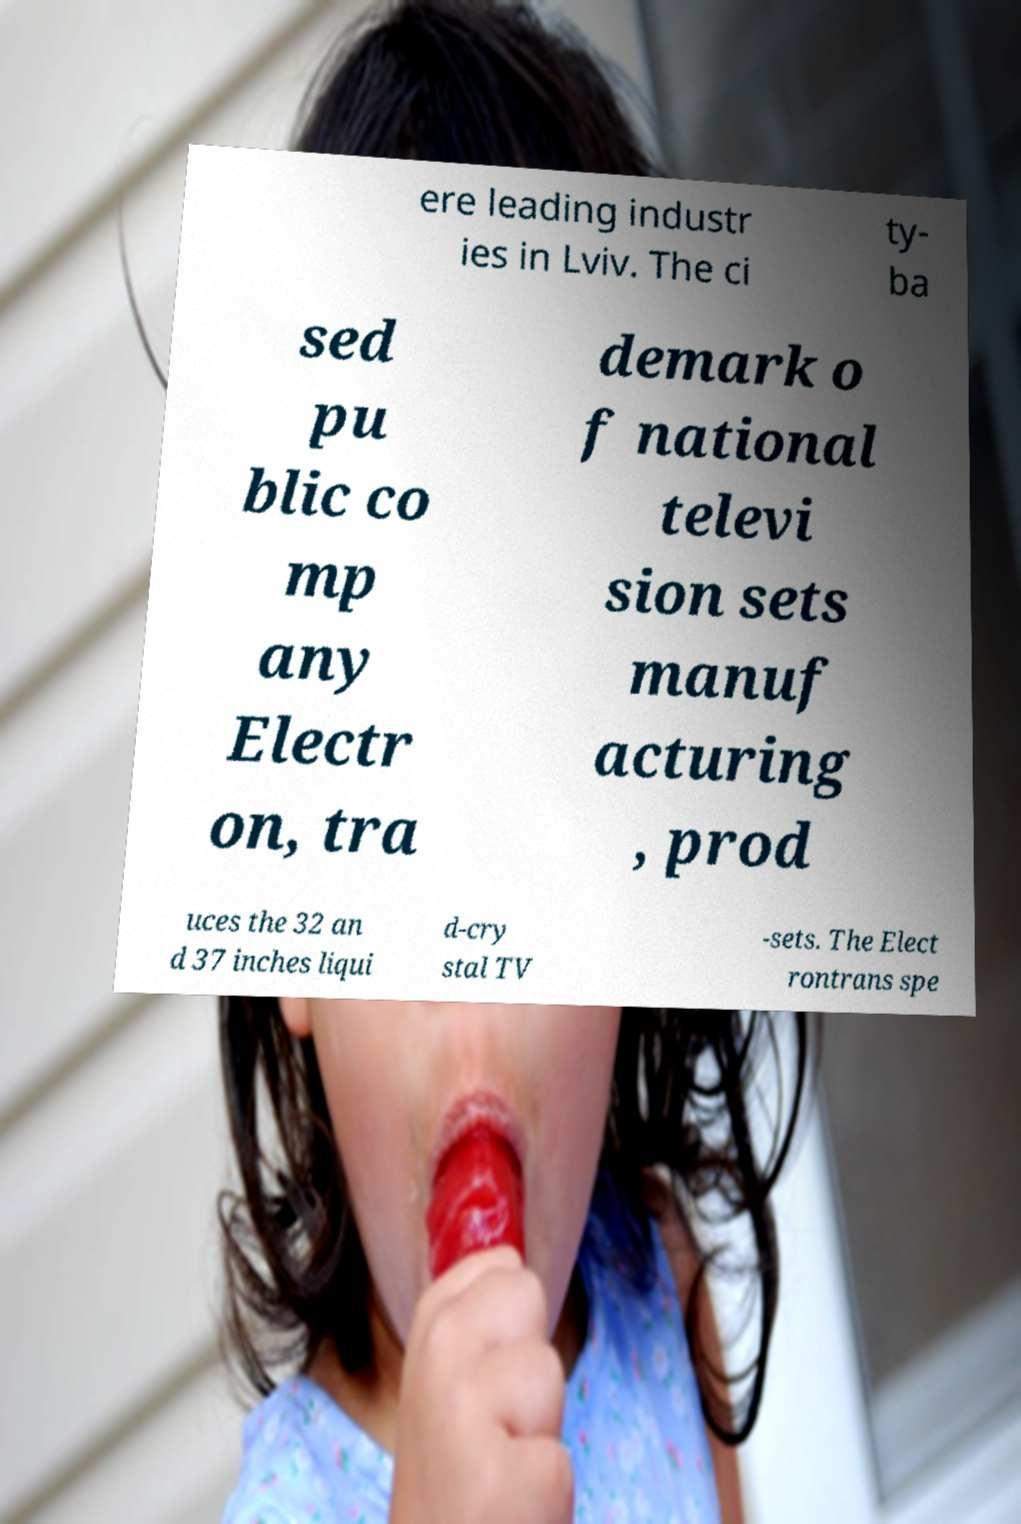Can you accurately transcribe the text from the provided image for me? ere leading industr ies in Lviv. The ci ty- ba sed pu blic co mp any Electr on, tra demark o f national televi sion sets manuf acturing , prod uces the 32 an d 37 inches liqui d-cry stal TV -sets. The Elect rontrans spe 